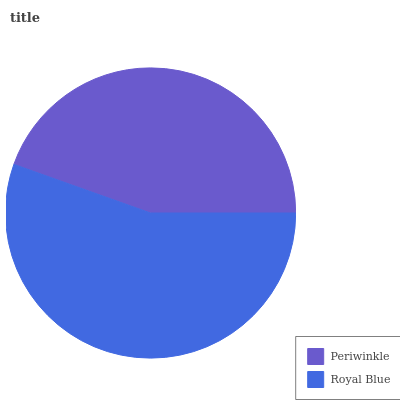Is Periwinkle the minimum?
Answer yes or no. Yes. Is Royal Blue the maximum?
Answer yes or no. Yes. Is Royal Blue the minimum?
Answer yes or no. No. Is Royal Blue greater than Periwinkle?
Answer yes or no. Yes. Is Periwinkle less than Royal Blue?
Answer yes or no. Yes. Is Periwinkle greater than Royal Blue?
Answer yes or no. No. Is Royal Blue less than Periwinkle?
Answer yes or no. No. Is Royal Blue the high median?
Answer yes or no. Yes. Is Periwinkle the low median?
Answer yes or no. Yes. Is Periwinkle the high median?
Answer yes or no. No. Is Royal Blue the low median?
Answer yes or no. No. 